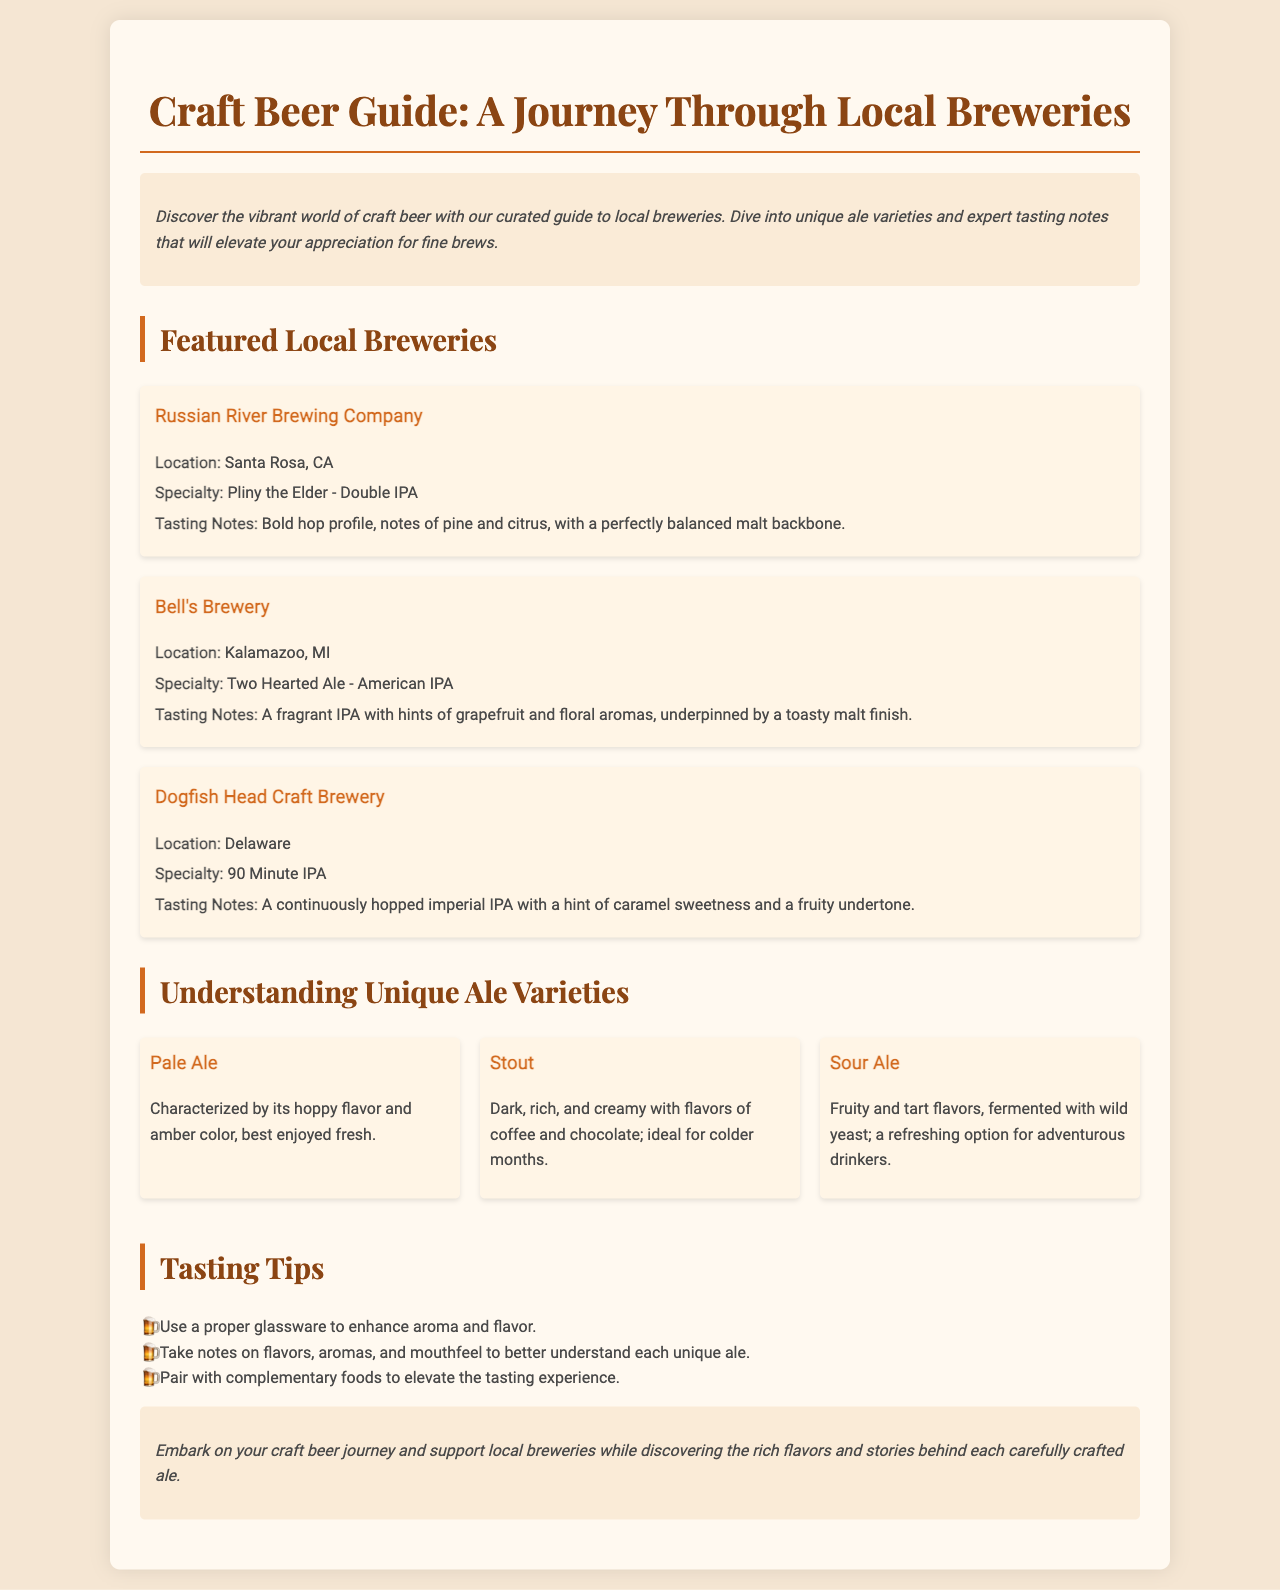What is the title of the guide? The title of the guide is mentioned prominently at the beginning of the document.
Answer: Craft Beer Guide: A Journey Through Local Breweries Where is Russian River Brewing Company located? The location of Russian River Brewing Company is specified in the brewery section.
Answer: Santa Rosa, CA What specialty beer does Bell's Brewery offer? The specialty beer of Bell's Brewery is detailed in the brewery overview.
Answer: Two Hearted Ale - American IPA Which ale type is characterized by fruity and tart flavors? The ale type with fruity and tart flavors is listed under unique ale varieties.
Answer: Sour Ale What are two tasting tips provided in the guide? The guide lists multiple tasting tips, providing specific suggestions for enhancing the tasting experience.
Answer: Use a proper glassware, Take notes on flavors What is the specialty of Dogfish Head Craft Brewery? The specialty of Dogfish Head Craft Brewery is mentioned in their specific section.
Answer: 90 Minute IPA How many featured local breweries are listed in the guide? The number of breweries featured in the document can be counted from the brewery sections.
Answer: Three What color is a Pale Ale typically? The typical color of Pale Ale is described in its definition.
Answer: Amber 